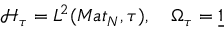Convert formula to latex. <formula><loc_0><loc_0><loc_500><loc_500>\mathcal { H } _ { \tau } = L ^ { 2 } ( M a t _ { N } , \tau ) , \quad \Omega _ { \tau } = \underline { 1 }</formula> 